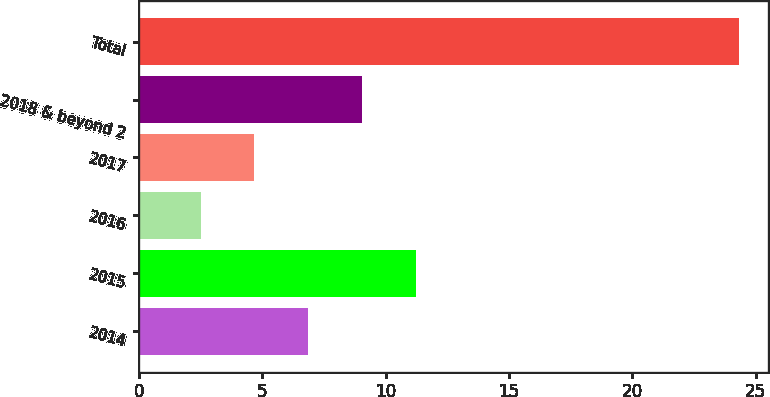Convert chart to OTSL. <chart><loc_0><loc_0><loc_500><loc_500><bar_chart><fcel>2014<fcel>2015<fcel>2016<fcel>2017<fcel>2018 & beyond 2<fcel>Total<nl><fcel>6.86<fcel>11.22<fcel>2.5<fcel>4.68<fcel>9.04<fcel>24.3<nl></chart> 